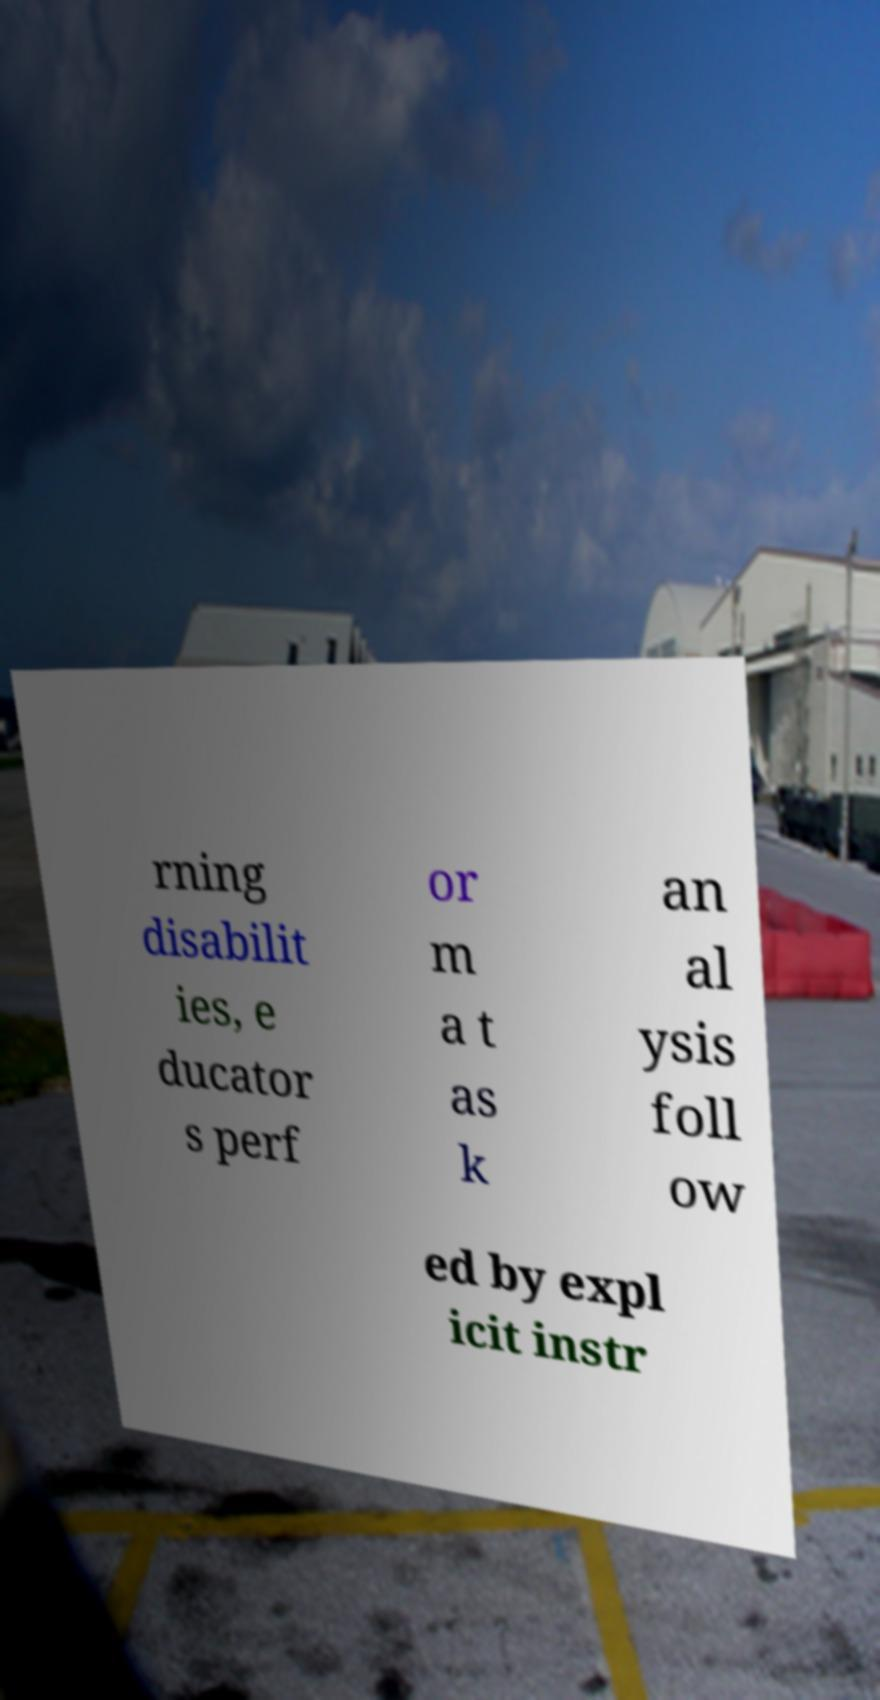Could you assist in decoding the text presented in this image and type it out clearly? rning disabilit ies, e ducator s perf or m a t as k an al ysis foll ow ed by expl icit instr 